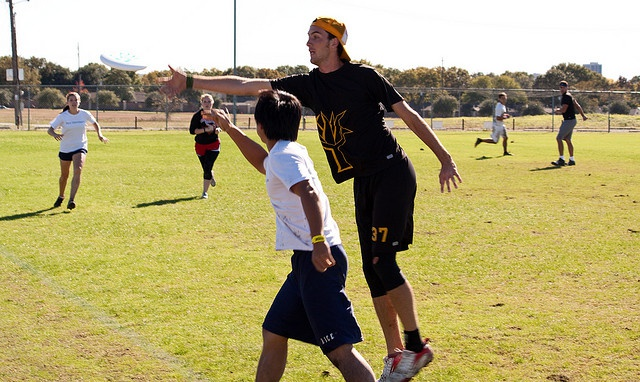Describe the objects in this image and their specific colors. I can see people in white, black, maroon, and brown tones, people in white, black, maroon, and darkgray tones, people in white, darkgray, brown, and black tones, people in white, black, gray, and maroon tones, and people in white, black, maroon, and gray tones in this image. 